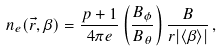Convert formula to latex. <formula><loc_0><loc_0><loc_500><loc_500>n _ { e } ( \vec { r } , \beta ) = \frac { p + 1 } { 4 \pi e } \left ( \frac { B _ { \phi } } { B _ { \theta } } \right ) \frac { B } { r | \langle \beta \rangle | } \, ,</formula> 